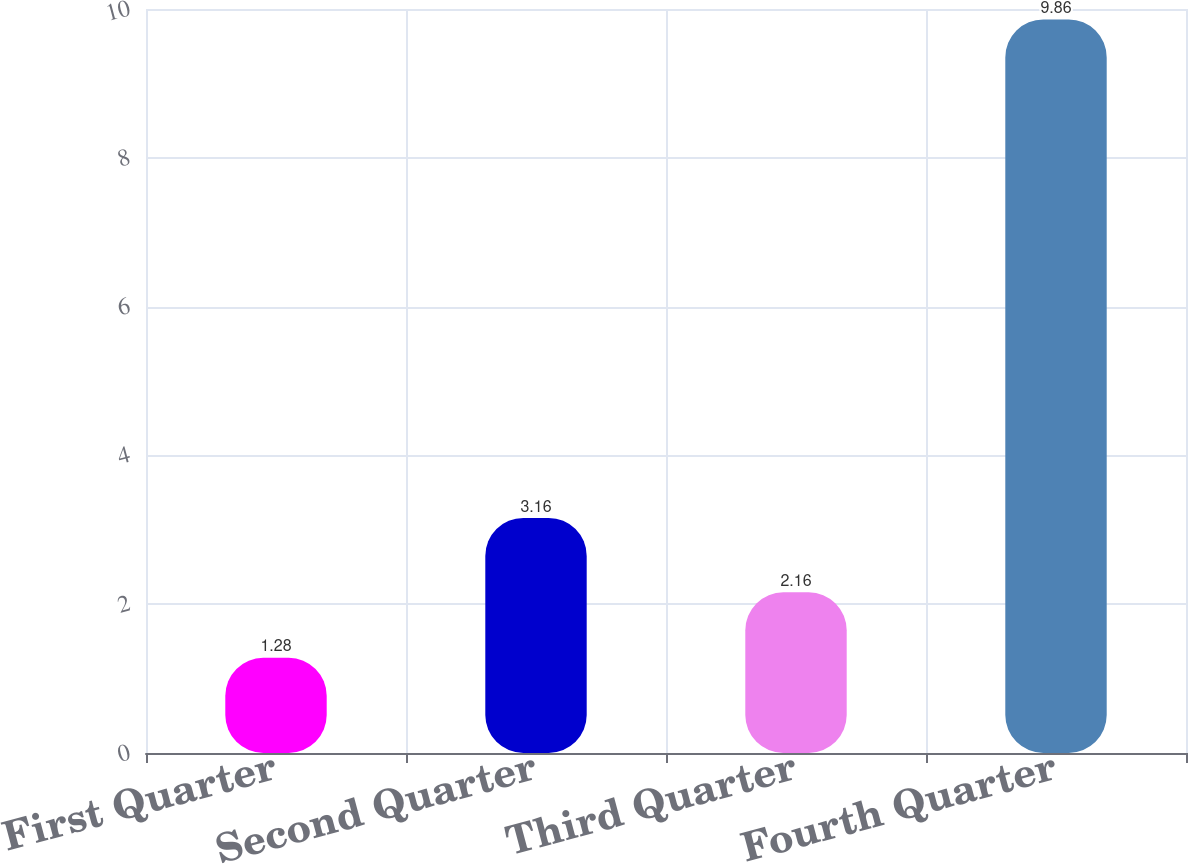<chart> <loc_0><loc_0><loc_500><loc_500><bar_chart><fcel>First Quarter<fcel>Second Quarter<fcel>Third Quarter<fcel>Fourth Quarter<nl><fcel>1.28<fcel>3.16<fcel>2.16<fcel>9.86<nl></chart> 